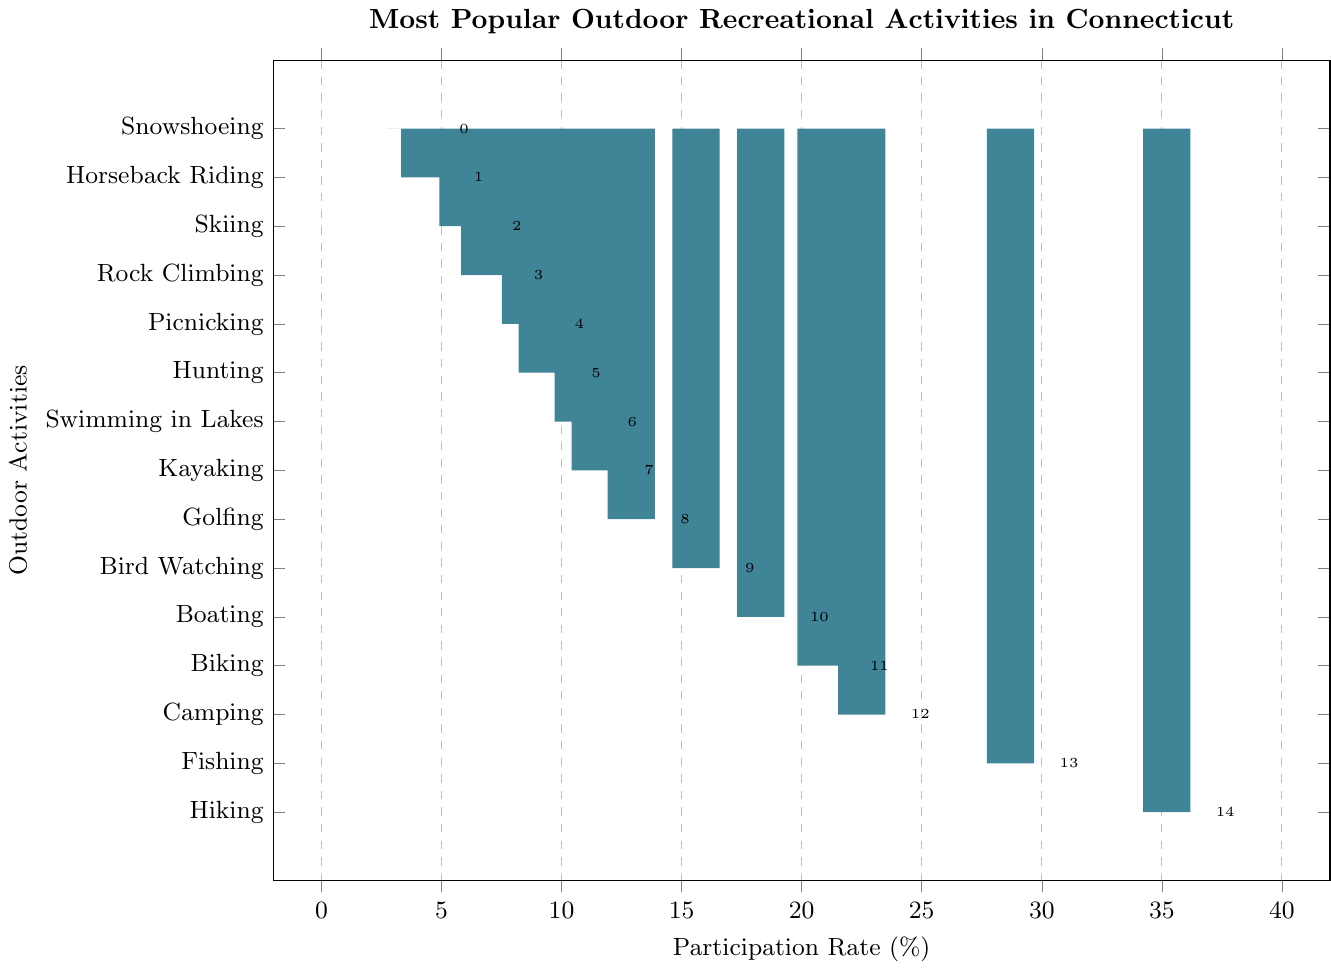Which outdoor activity has the highest participation rate? The activity with the tallest bar represents the highest participation rate. Here, "Hiking" has the tallest bar.
Answer: Hiking What is the participation rate for Rock Climbing? Locate the bar labeled "Rock Climbing" and read the value at the end of the bar. The participation rate is noted as 6.8%.
Answer: 6.8% Which outdoor activity has a higher participation rate: Boating or Kayaking? Compare the heights of the bars for "Boating" and "Kayaking." The "Boating" bar is taller at 18.3%, compared to "Kayaking" at 11.4%.
Answer: Boating What is the total participation rate for activities Fishing and Camping? Add the participation rates for Fishing (28.7%) and Camping (22.5%). So, 28.7 + 22.5 = 51.2%.
Answer: 51.2% Which activity has the lowest participation rate, and what is it? The activity with the shortest bar has the lowest participation rate. "Snowshoeing" has the shortest bar at 3.7%.
Answer: Snowshoeing, 3.7% How much higher is the participation rate for Hiking compared to Picnicking? Subtract the participation rate for Picnicking (8.5%) from Hiking (35.2%). So, 35.2 - 8.5 = 26.7%.
Answer: 26.7% Which activities have participation rates greater than 20%? Identify all bars that extend beyond the 20% mark. These activities are Hiking (35.2%), Fishing (28.7%), Camping (22.5%), and Biking (20.8%).
Answer: Hiking, Fishing, Camping, Biking What is the average participation rate for Skiing, Golfing, and Bird Watching? Add the participation rates for Skiing (5.9%), Golfing (12.9%), and Bird Watching (15.6%), then divide by the number of activities (3). (5.9 + 12.9 + 15.6) / 3 = 34.4 / 3 = 11.47%.
Answer: 11.47% Compare the participation rates of Hunting and Horseback Riding. Are they close? The participation rate for Hunting is 9.2%, and for Horseback Riding, it is 4.3%. The difference is 9.2 - 4.3 = 4.9%, indicating they are not very close.
Answer: No If the participation rates for Kayaking and Skiing were swapped, which activity's participation rate would increase the most? Kayaking's current rate is 11.4%, and Skiing’s is 5.9%. After swapping, Skiing would increase from 5.9% to 11.4%, an increase of 11.4 - 5.9 = 5.5%.
Answer: Skiing 